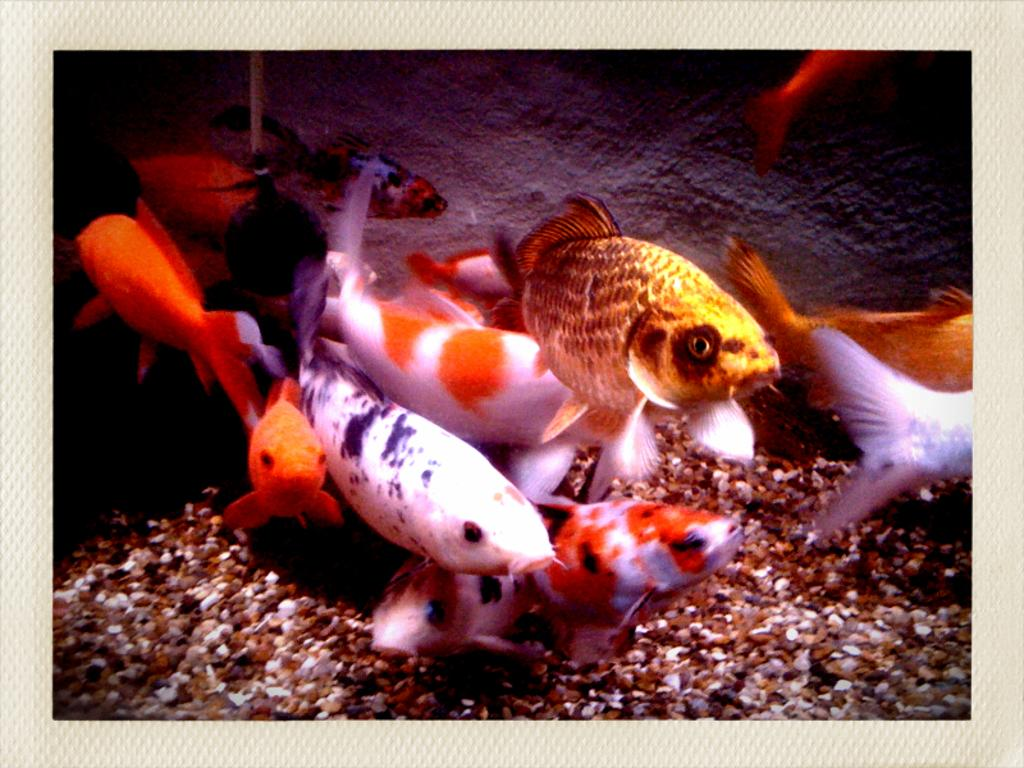What type of animals can be seen in the image? There are fishes in the image. What other objects are present in the image? There are stones in the image. What is the background of the image? There is a wall in the image. What color is the border of the image? The border of the image is white. Can you tell me how many pies are on the wall in the image? There are no pies present in the image; it features fishes, stones, and a wall. Is there a baby visible in the image? There is no baby present in the image. 